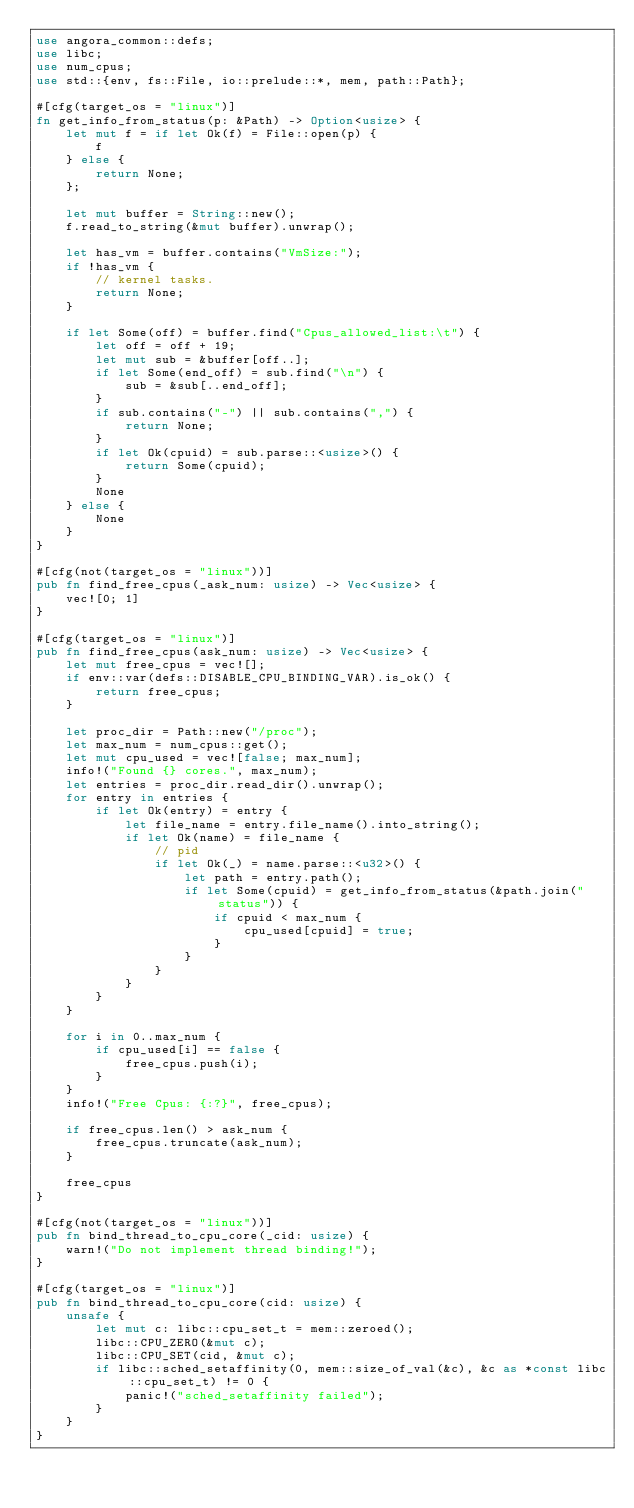<code> <loc_0><loc_0><loc_500><loc_500><_Rust_>use angora_common::defs;
use libc;
use num_cpus;
use std::{env, fs::File, io::prelude::*, mem, path::Path};

#[cfg(target_os = "linux")]
fn get_info_from_status(p: &Path) -> Option<usize> {
    let mut f = if let Ok(f) = File::open(p) {
        f
    } else {
        return None;
    };

    let mut buffer = String::new();
    f.read_to_string(&mut buffer).unwrap();

    let has_vm = buffer.contains("VmSize:");
    if !has_vm {
        // kernel tasks.
        return None;
    }

    if let Some(off) = buffer.find("Cpus_allowed_list:\t") {
        let off = off + 19;
        let mut sub = &buffer[off..];
        if let Some(end_off) = sub.find("\n") {
            sub = &sub[..end_off];
        }
        if sub.contains("-") || sub.contains(",") {
            return None;
        }
        if let Ok(cpuid) = sub.parse::<usize>() {
            return Some(cpuid);
        }
        None
    } else {
        None
    }
}

#[cfg(not(target_os = "linux"))]
pub fn find_free_cpus(_ask_num: usize) -> Vec<usize> {
    vec![0; 1]
}

#[cfg(target_os = "linux")]
pub fn find_free_cpus(ask_num: usize) -> Vec<usize> {
    let mut free_cpus = vec![];
    if env::var(defs::DISABLE_CPU_BINDING_VAR).is_ok() {
        return free_cpus;
    }

    let proc_dir = Path::new("/proc");
    let max_num = num_cpus::get();
    let mut cpu_used = vec![false; max_num];
    info!("Found {} cores.", max_num);
    let entries = proc_dir.read_dir().unwrap();
    for entry in entries {
        if let Ok(entry) = entry {
            let file_name = entry.file_name().into_string();
            if let Ok(name) = file_name {
                // pid
                if let Ok(_) = name.parse::<u32>() {
                    let path = entry.path();
                    if let Some(cpuid) = get_info_from_status(&path.join("status")) {
                        if cpuid < max_num {
                            cpu_used[cpuid] = true;
                        }
                    }
                }
            }
        }
    }

    for i in 0..max_num {
        if cpu_used[i] == false {
            free_cpus.push(i);
        }
    }
    info!("Free Cpus: {:?}", free_cpus);

    if free_cpus.len() > ask_num {
        free_cpus.truncate(ask_num);
    }

    free_cpus
}

#[cfg(not(target_os = "linux"))]
pub fn bind_thread_to_cpu_core(_cid: usize) {
    warn!("Do not implement thread binding!");
}

#[cfg(target_os = "linux")]
pub fn bind_thread_to_cpu_core(cid: usize) {
    unsafe {
        let mut c: libc::cpu_set_t = mem::zeroed();
        libc::CPU_ZERO(&mut c);
        libc::CPU_SET(cid, &mut c);
        if libc::sched_setaffinity(0, mem::size_of_val(&c), &c as *const libc::cpu_set_t) != 0 {
            panic!("sched_setaffinity failed");
        }
    }
}
</code> 